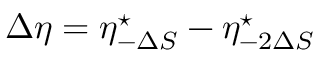Convert formula to latex. <formula><loc_0><loc_0><loc_500><loc_500>\Delta \eta = \eta _ { - \Delta S } ^ { ^ { * } } - \eta _ { - 2 \Delta S } ^ { ^ { * } }</formula> 